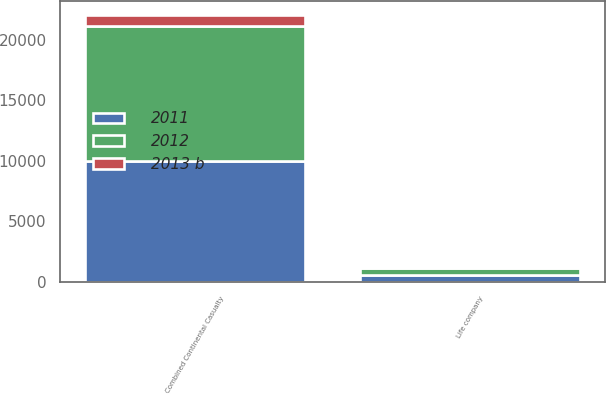<chart> <loc_0><loc_0><loc_500><loc_500><stacked_bar_chart><ecel><fcel>Combined Continental Casualty<fcel>Life company<nl><fcel>2012<fcel>11137<fcel>597<nl><fcel>2011<fcel>9998<fcel>556<nl><fcel>2013 b<fcel>954<fcel>29<nl></chart> 